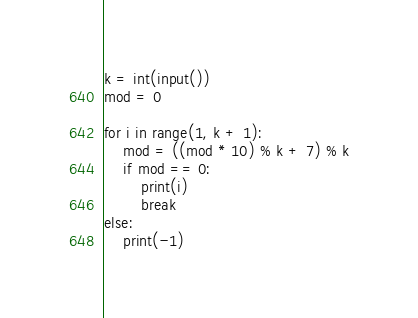Convert code to text. <code><loc_0><loc_0><loc_500><loc_500><_Python_>k = int(input())
mod = 0

for i in range(1, k + 1):
    mod = ((mod * 10) % k + 7) % k
    if mod == 0:
        print(i)
        break
else:
    print(-1)
</code> 